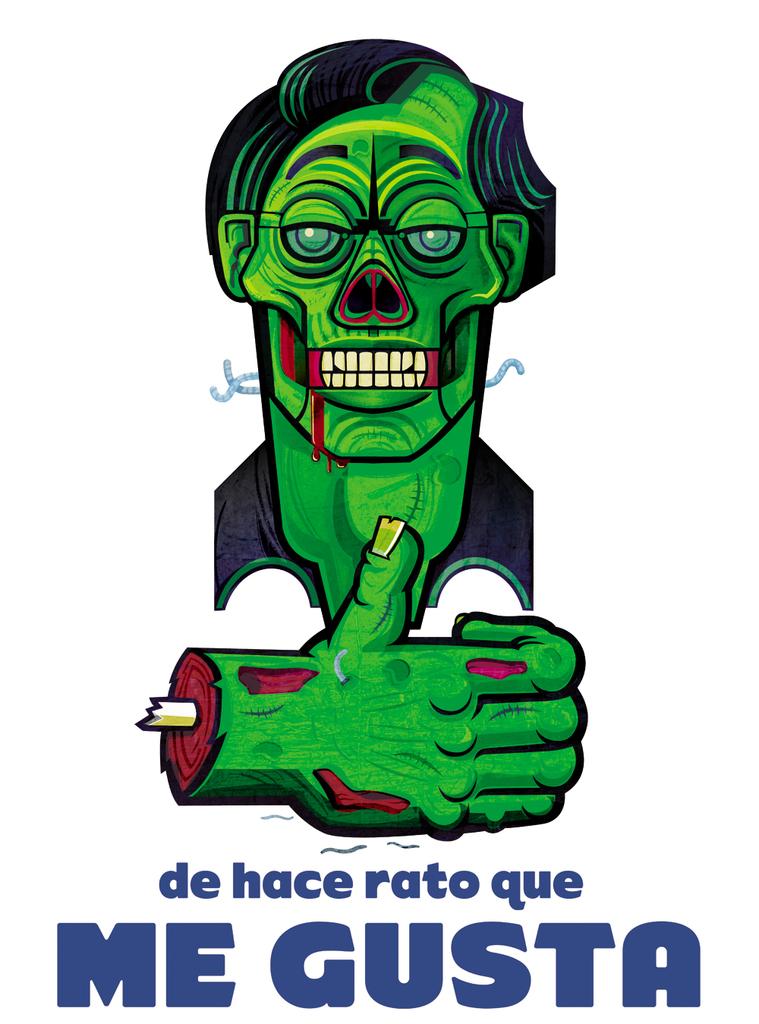What is the last word?
Provide a succinct answer. Gusta. What is the first letter of the bottom line?
Provide a short and direct response. M. 